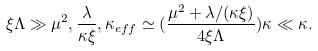Convert formula to latex. <formula><loc_0><loc_0><loc_500><loc_500>\xi \Lambda \gg \mu ^ { 2 } , \frac { \lambda } { \kappa \xi } , \kappa _ { e f f } \simeq ( \frac { \mu ^ { 2 } + \lambda / ( \kappa \xi ) } { 4 \xi \Lambda } ) \kappa \ll \kappa .</formula> 